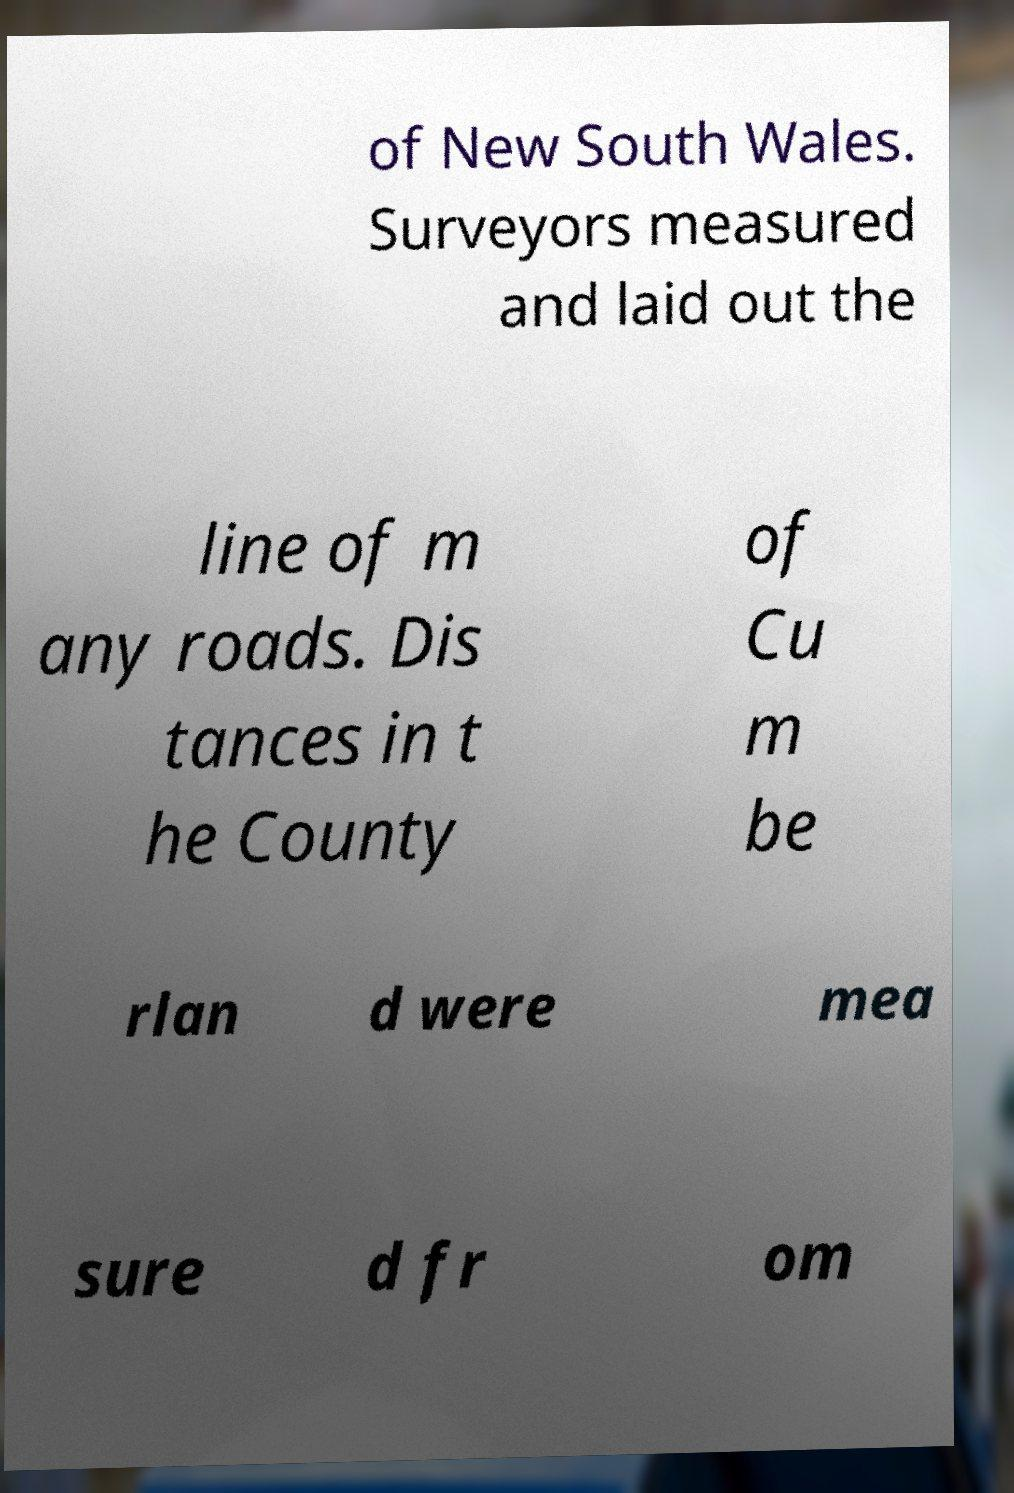Could you extract and type out the text from this image? of New South Wales. Surveyors measured and laid out the line of m any roads. Dis tances in t he County of Cu m be rlan d were mea sure d fr om 